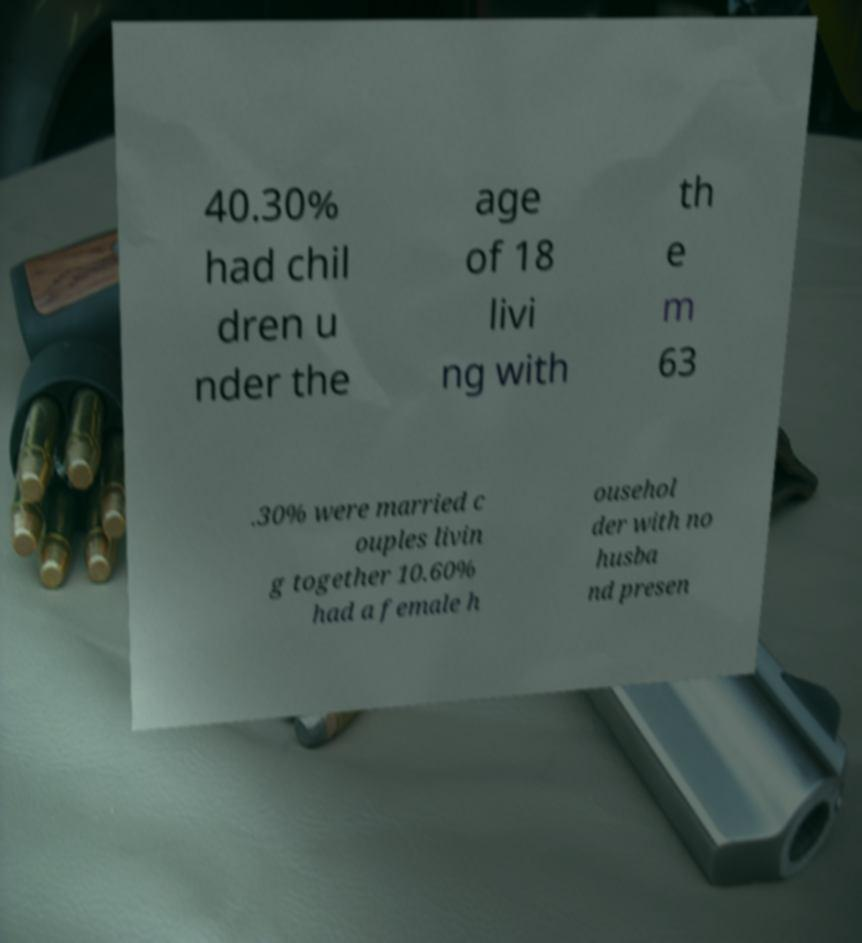What messages or text are displayed in this image? I need them in a readable, typed format. 40.30% had chil dren u nder the age of 18 livi ng with th e m 63 .30% were married c ouples livin g together 10.60% had a female h ousehol der with no husba nd presen 